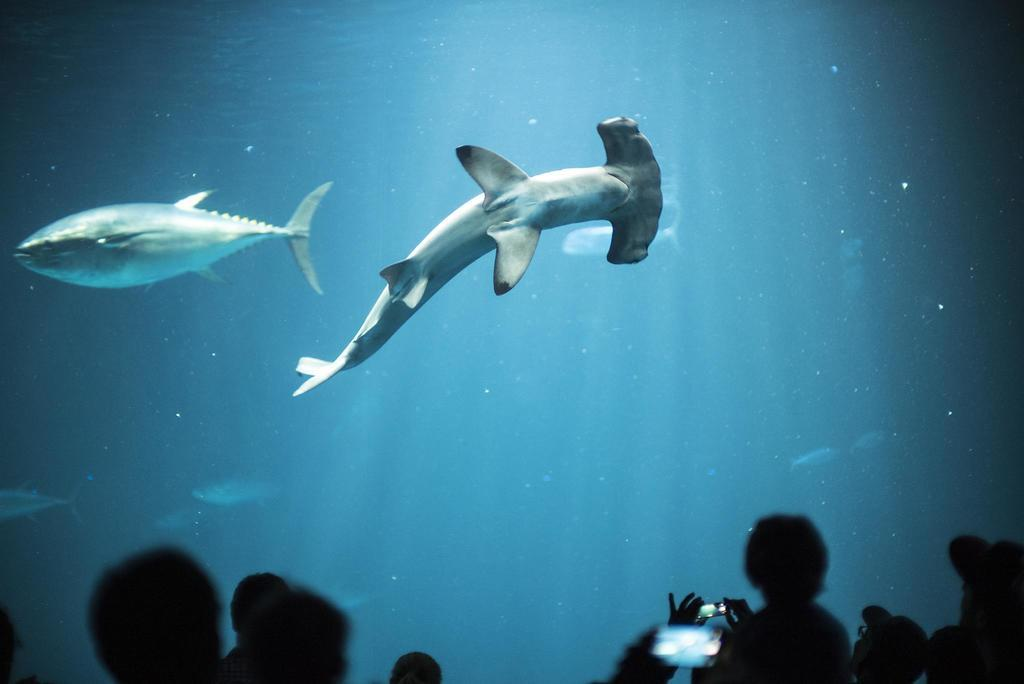What type of animals can be seen in the water in the image? There are fishes in the water in the image. Where are the people located in the image? The people are at the bottom of the image. What are some of the people doing in the image? Some of the people are capturing pictures. What type of grip can be seen on the icicle in the image? There is no icicle present in the image, so it is not possible to determine the type of grip on it. 